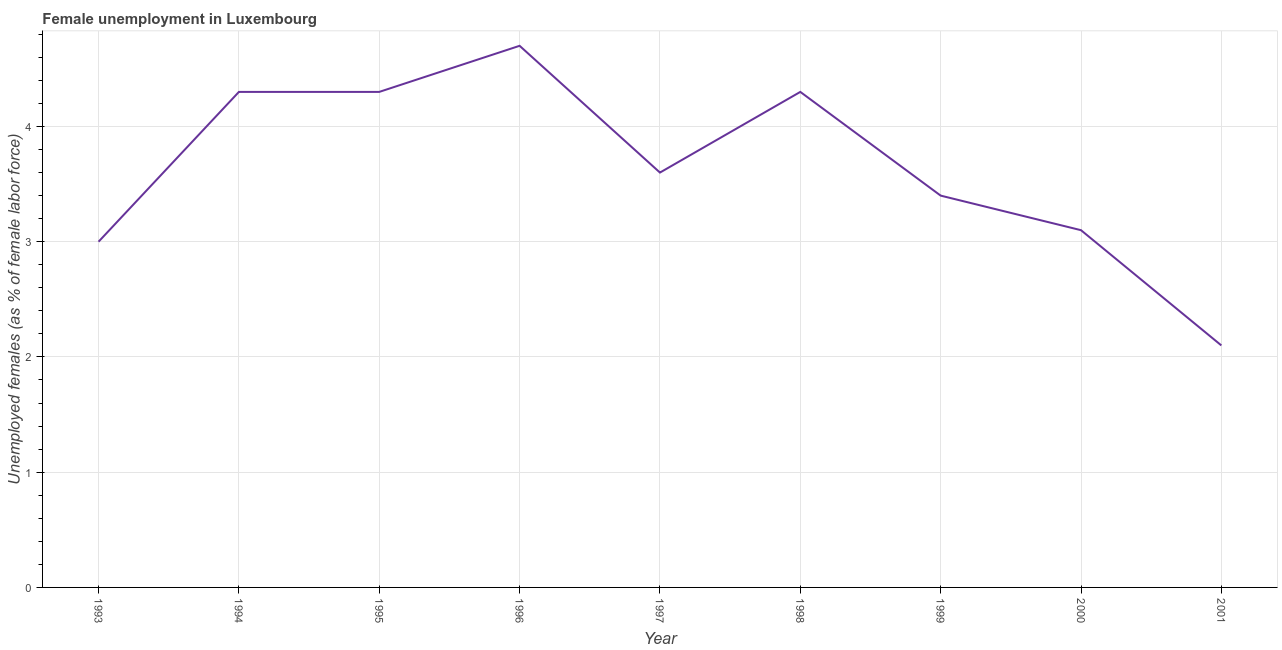What is the unemployed females population in 1995?
Make the answer very short. 4.3. Across all years, what is the maximum unemployed females population?
Give a very brief answer. 4.7. Across all years, what is the minimum unemployed females population?
Keep it short and to the point. 2.1. In which year was the unemployed females population maximum?
Your answer should be very brief. 1996. What is the sum of the unemployed females population?
Your answer should be compact. 32.8. What is the difference between the unemployed females population in 1999 and 2000?
Offer a very short reply. 0.3. What is the average unemployed females population per year?
Your answer should be compact. 3.64. What is the median unemployed females population?
Provide a short and direct response. 3.6. In how many years, is the unemployed females population greater than 0.4 %?
Offer a very short reply. 9. Do a majority of the years between 2001 and 2000 (inclusive) have unemployed females population greater than 4 %?
Ensure brevity in your answer.  No. What is the ratio of the unemployed females population in 1993 to that in 2000?
Keep it short and to the point. 0.97. Is the unemployed females population in 1993 less than that in 2001?
Your response must be concise. No. Is the difference between the unemployed females population in 1994 and 1995 greater than the difference between any two years?
Offer a very short reply. No. What is the difference between the highest and the second highest unemployed females population?
Your response must be concise. 0.4. Is the sum of the unemployed females population in 1993 and 1999 greater than the maximum unemployed females population across all years?
Offer a very short reply. Yes. What is the difference between the highest and the lowest unemployed females population?
Your response must be concise. 2.6. How many years are there in the graph?
Make the answer very short. 9. What is the difference between two consecutive major ticks on the Y-axis?
Offer a terse response. 1. Are the values on the major ticks of Y-axis written in scientific E-notation?
Your answer should be compact. No. What is the title of the graph?
Your response must be concise. Female unemployment in Luxembourg. What is the label or title of the Y-axis?
Provide a succinct answer. Unemployed females (as % of female labor force). What is the Unemployed females (as % of female labor force) of 1994?
Keep it short and to the point. 4.3. What is the Unemployed females (as % of female labor force) of 1995?
Provide a short and direct response. 4.3. What is the Unemployed females (as % of female labor force) of 1996?
Offer a very short reply. 4.7. What is the Unemployed females (as % of female labor force) in 1997?
Offer a terse response. 3.6. What is the Unemployed females (as % of female labor force) in 1998?
Provide a succinct answer. 4.3. What is the Unemployed females (as % of female labor force) of 1999?
Offer a terse response. 3.4. What is the Unemployed females (as % of female labor force) in 2000?
Ensure brevity in your answer.  3.1. What is the Unemployed females (as % of female labor force) in 2001?
Your answer should be very brief. 2.1. What is the difference between the Unemployed females (as % of female labor force) in 1993 and 1996?
Keep it short and to the point. -1.7. What is the difference between the Unemployed females (as % of female labor force) in 1993 and 1997?
Make the answer very short. -0.6. What is the difference between the Unemployed females (as % of female labor force) in 1993 and 1999?
Keep it short and to the point. -0.4. What is the difference between the Unemployed females (as % of female labor force) in 1993 and 2000?
Your answer should be compact. -0.1. What is the difference between the Unemployed females (as % of female labor force) in 1993 and 2001?
Provide a succinct answer. 0.9. What is the difference between the Unemployed females (as % of female labor force) in 1994 and 1996?
Your answer should be very brief. -0.4. What is the difference between the Unemployed females (as % of female labor force) in 1994 and 1997?
Keep it short and to the point. 0.7. What is the difference between the Unemployed females (as % of female labor force) in 1994 and 1998?
Make the answer very short. 0. What is the difference between the Unemployed females (as % of female labor force) in 1994 and 1999?
Your answer should be compact. 0.9. What is the difference between the Unemployed females (as % of female labor force) in 1994 and 2000?
Provide a succinct answer. 1.2. What is the difference between the Unemployed females (as % of female labor force) in 1995 and 1996?
Your response must be concise. -0.4. What is the difference between the Unemployed females (as % of female labor force) in 1995 and 1999?
Your answer should be compact. 0.9. What is the difference between the Unemployed females (as % of female labor force) in 1995 and 2000?
Offer a very short reply. 1.2. What is the difference between the Unemployed females (as % of female labor force) in 1995 and 2001?
Offer a very short reply. 2.2. What is the difference between the Unemployed females (as % of female labor force) in 1996 and 1998?
Make the answer very short. 0.4. What is the difference between the Unemployed females (as % of female labor force) in 1996 and 1999?
Make the answer very short. 1.3. What is the difference between the Unemployed females (as % of female labor force) in 1996 and 2000?
Your answer should be very brief. 1.6. What is the difference between the Unemployed females (as % of female labor force) in 1996 and 2001?
Keep it short and to the point. 2.6. What is the difference between the Unemployed females (as % of female labor force) in 1997 and 1999?
Provide a short and direct response. 0.2. What is the difference between the Unemployed females (as % of female labor force) in 1997 and 2001?
Your response must be concise. 1.5. What is the difference between the Unemployed females (as % of female labor force) in 1998 and 1999?
Provide a short and direct response. 0.9. What is the difference between the Unemployed females (as % of female labor force) in 1999 and 2001?
Offer a very short reply. 1.3. What is the ratio of the Unemployed females (as % of female labor force) in 1993 to that in 1994?
Your response must be concise. 0.7. What is the ratio of the Unemployed females (as % of female labor force) in 1993 to that in 1995?
Offer a terse response. 0.7. What is the ratio of the Unemployed females (as % of female labor force) in 1993 to that in 1996?
Offer a very short reply. 0.64. What is the ratio of the Unemployed females (as % of female labor force) in 1993 to that in 1997?
Give a very brief answer. 0.83. What is the ratio of the Unemployed females (as % of female labor force) in 1993 to that in 1998?
Your response must be concise. 0.7. What is the ratio of the Unemployed females (as % of female labor force) in 1993 to that in 1999?
Give a very brief answer. 0.88. What is the ratio of the Unemployed females (as % of female labor force) in 1993 to that in 2001?
Offer a terse response. 1.43. What is the ratio of the Unemployed females (as % of female labor force) in 1994 to that in 1996?
Make the answer very short. 0.92. What is the ratio of the Unemployed females (as % of female labor force) in 1994 to that in 1997?
Provide a succinct answer. 1.19. What is the ratio of the Unemployed females (as % of female labor force) in 1994 to that in 1998?
Ensure brevity in your answer.  1. What is the ratio of the Unemployed females (as % of female labor force) in 1994 to that in 1999?
Offer a terse response. 1.26. What is the ratio of the Unemployed females (as % of female labor force) in 1994 to that in 2000?
Your answer should be compact. 1.39. What is the ratio of the Unemployed females (as % of female labor force) in 1994 to that in 2001?
Provide a short and direct response. 2.05. What is the ratio of the Unemployed females (as % of female labor force) in 1995 to that in 1996?
Provide a short and direct response. 0.92. What is the ratio of the Unemployed females (as % of female labor force) in 1995 to that in 1997?
Offer a very short reply. 1.19. What is the ratio of the Unemployed females (as % of female labor force) in 1995 to that in 1998?
Ensure brevity in your answer.  1. What is the ratio of the Unemployed females (as % of female labor force) in 1995 to that in 1999?
Make the answer very short. 1.26. What is the ratio of the Unemployed females (as % of female labor force) in 1995 to that in 2000?
Your answer should be very brief. 1.39. What is the ratio of the Unemployed females (as % of female labor force) in 1995 to that in 2001?
Give a very brief answer. 2.05. What is the ratio of the Unemployed females (as % of female labor force) in 1996 to that in 1997?
Offer a terse response. 1.31. What is the ratio of the Unemployed females (as % of female labor force) in 1996 to that in 1998?
Offer a very short reply. 1.09. What is the ratio of the Unemployed females (as % of female labor force) in 1996 to that in 1999?
Offer a very short reply. 1.38. What is the ratio of the Unemployed females (as % of female labor force) in 1996 to that in 2000?
Offer a terse response. 1.52. What is the ratio of the Unemployed females (as % of female labor force) in 1996 to that in 2001?
Give a very brief answer. 2.24. What is the ratio of the Unemployed females (as % of female labor force) in 1997 to that in 1998?
Provide a short and direct response. 0.84. What is the ratio of the Unemployed females (as % of female labor force) in 1997 to that in 1999?
Ensure brevity in your answer.  1.06. What is the ratio of the Unemployed females (as % of female labor force) in 1997 to that in 2000?
Your answer should be very brief. 1.16. What is the ratio of the Unemployed females (as % of female labor force) in 1997 to that in 2001?
Your answer should be compact. 1.71. What is the ratio of the Unemployed females (as % of female labor force) in 1998 to that in 1999?
Offer a very short reply. 1.26. What is the ratio of the Unemployed females (as % of female labor force) in 1998 to that in 2000?
Provide a succinct answer. 1.39. What is the ratio of the Unemployed females (as % of female labor force) in 1998 to that in 2001?
Offer a very short reply. 2.05. What is the ratio of the Unemployed females (as % of female labor force) in 1999 to that in 2000?
Make the answer very short. 1.1. What is the ratio of the Unemployed females (as % of female labor force) in 1999 to that in 2001?
Provide a short and direct response. 1.62. What is the ratio of the Unemployed females (as % of female labor force) in 2000 to that in 2001?
Offer a very short reply. 1.48. 